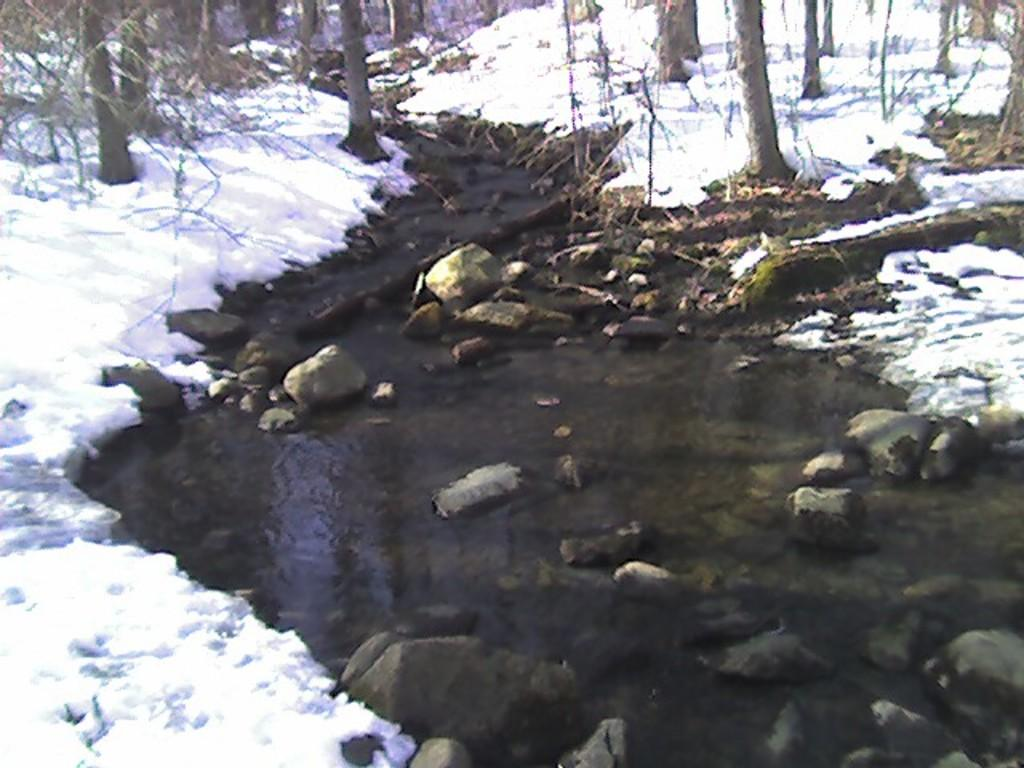What type of natural feature is present in the image? There is a river in the image. What is the condition of the ground on both sides of the river? Snow is visible on both sides of the river. What can be found in the water of the river? There are stones in the water. What type of vegetation is visible in the background of the image? There are trees in the background of the image. What type of wool is being used to create the feather in the image? There is no wool or feather present in the image. 